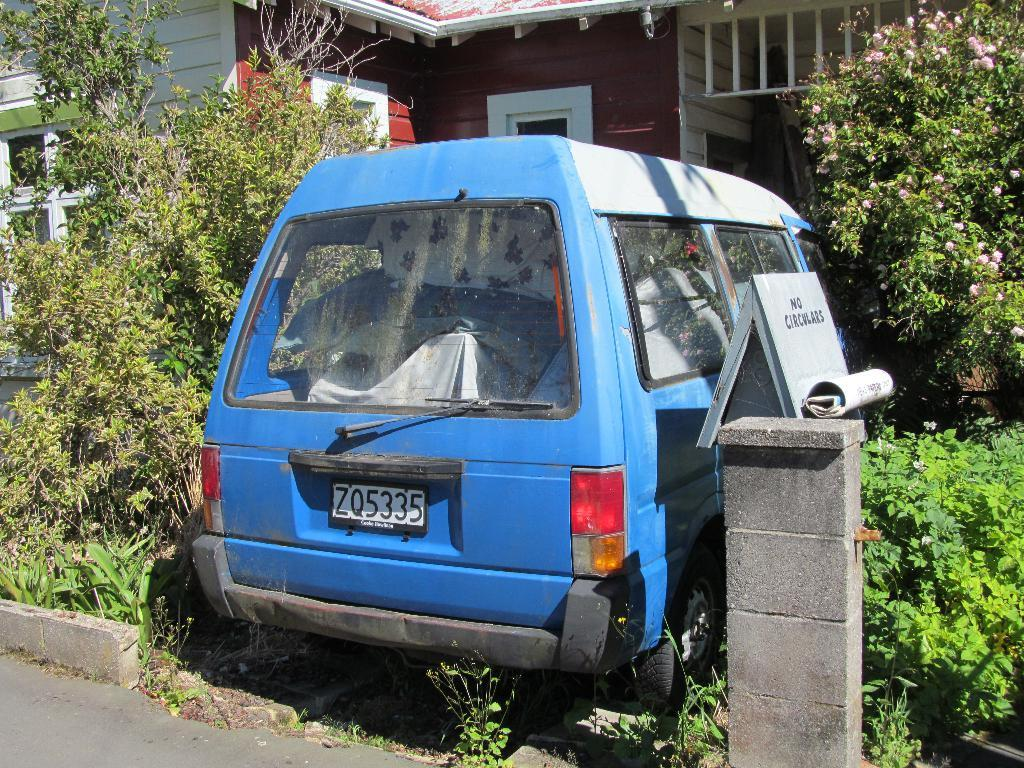<image>
Present a compact description of the photo's key features. A blue van with the license plate ZQ5335 sets in an overgrown driveway. 